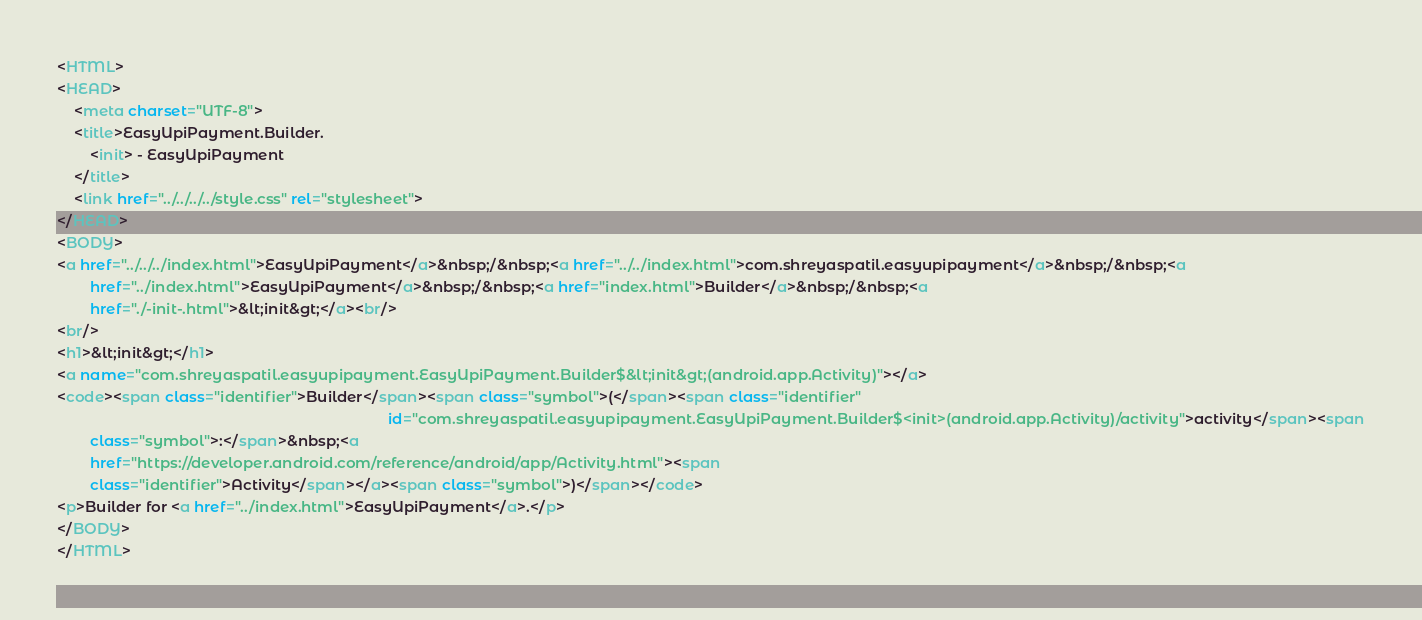Convert code to text. <code><loc_0><loc_0><loc_500><loc_500><_HTML_><HTML>
<HEAD>
    <meta charset="UTF-8">
    <title>EasyUpiPayment.Builder.
        <init> - EasyUpiPayment
    </title>
    <link href="../../../../style.css" rel="stylesheet">
</HEAD>
<BODY>
<a href="../../../index.html">EasyUpiPayment</a>&nbsp;/&nbsp;<a href="../../index.html">com.shreyaspatil.easyupipayment</a>&nbsp;/&nbsp;<a
        href="../index.html">EasyUpiPayment</a>&nbsp;/&nbsp;<a href="index.html">Builder</a>&nbsp;/&nbsp;<a
        href="./-init-.html">&lt;init&gt;</a><br/>
<br/>
<h1>&lt;init&gt;</h1>
<a name="com.shreyaspatil.easyupipayment.EasyUpiPayment.Builder$&lt;init&gt;(android.app.Activity)"></a>
<code><span class="identifier">Builder</span><span class="symbol">(</span><span class="identifier"
                                                                                id="com.shreyaspatil.easyupipayment.EasyUpiPayment.Builder$<init>(android.app.Activity)/activity">activity</span><span
        class="symbol">:</span>&nbsp;<a
        href="https://developer.android.com/reference/android/app/Activity.html"><span
        class="identifier">Activity</span></a><span class="symbol">)</span></code>
<p>Builder for <a href="../index.html">EasyUpiPayment</a>.</p>
</BODY>
</HTML>
</code> 